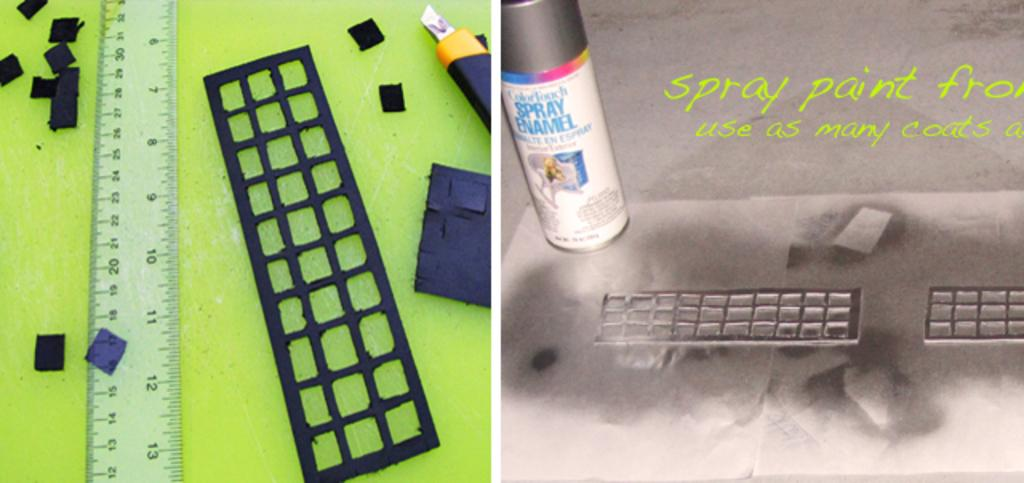Provide a one-sentence caption for the provided image. A can of ColorTouch Spray Enamel is being used with a stencil and ruler. 